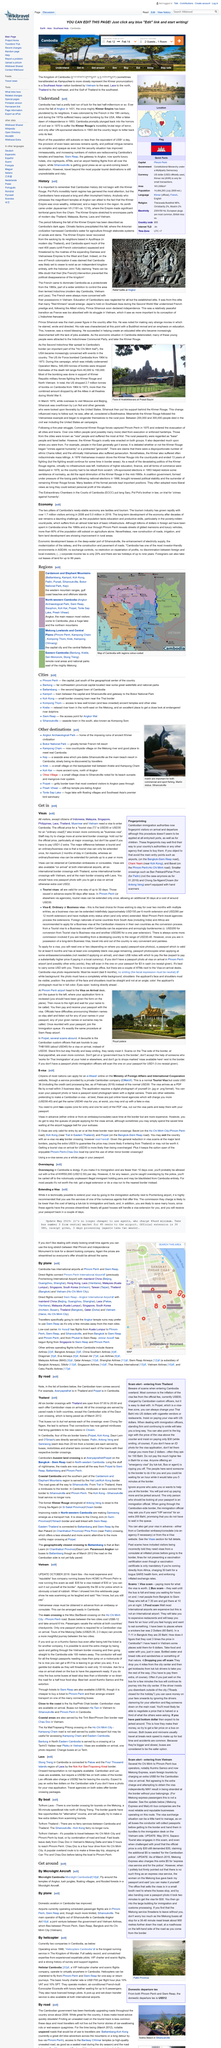Give some essential details in this illustration. Under the rule of Jayavarman VII, the Khmer empire extended to modern-day Thailand, Malaysia, Burma, Laos, and Vietnam, encompassing a vast geographical region and establishing the empire as a dominant force in Southeast Asia. The official price for a tourist visa to Cambodia is USD30. The fall of Angkor occurred in 1431. Cambodia began to rebuild and recover from the devastation caused by the Khmer Rouge's brutal reign of terror in 1993, following the un-sponsored elections held that year. In rural areas, new road construction, irrigation systems, and agricultural land development have demonstrated significant improvement, contributing to the overall growth and development of these regions. 